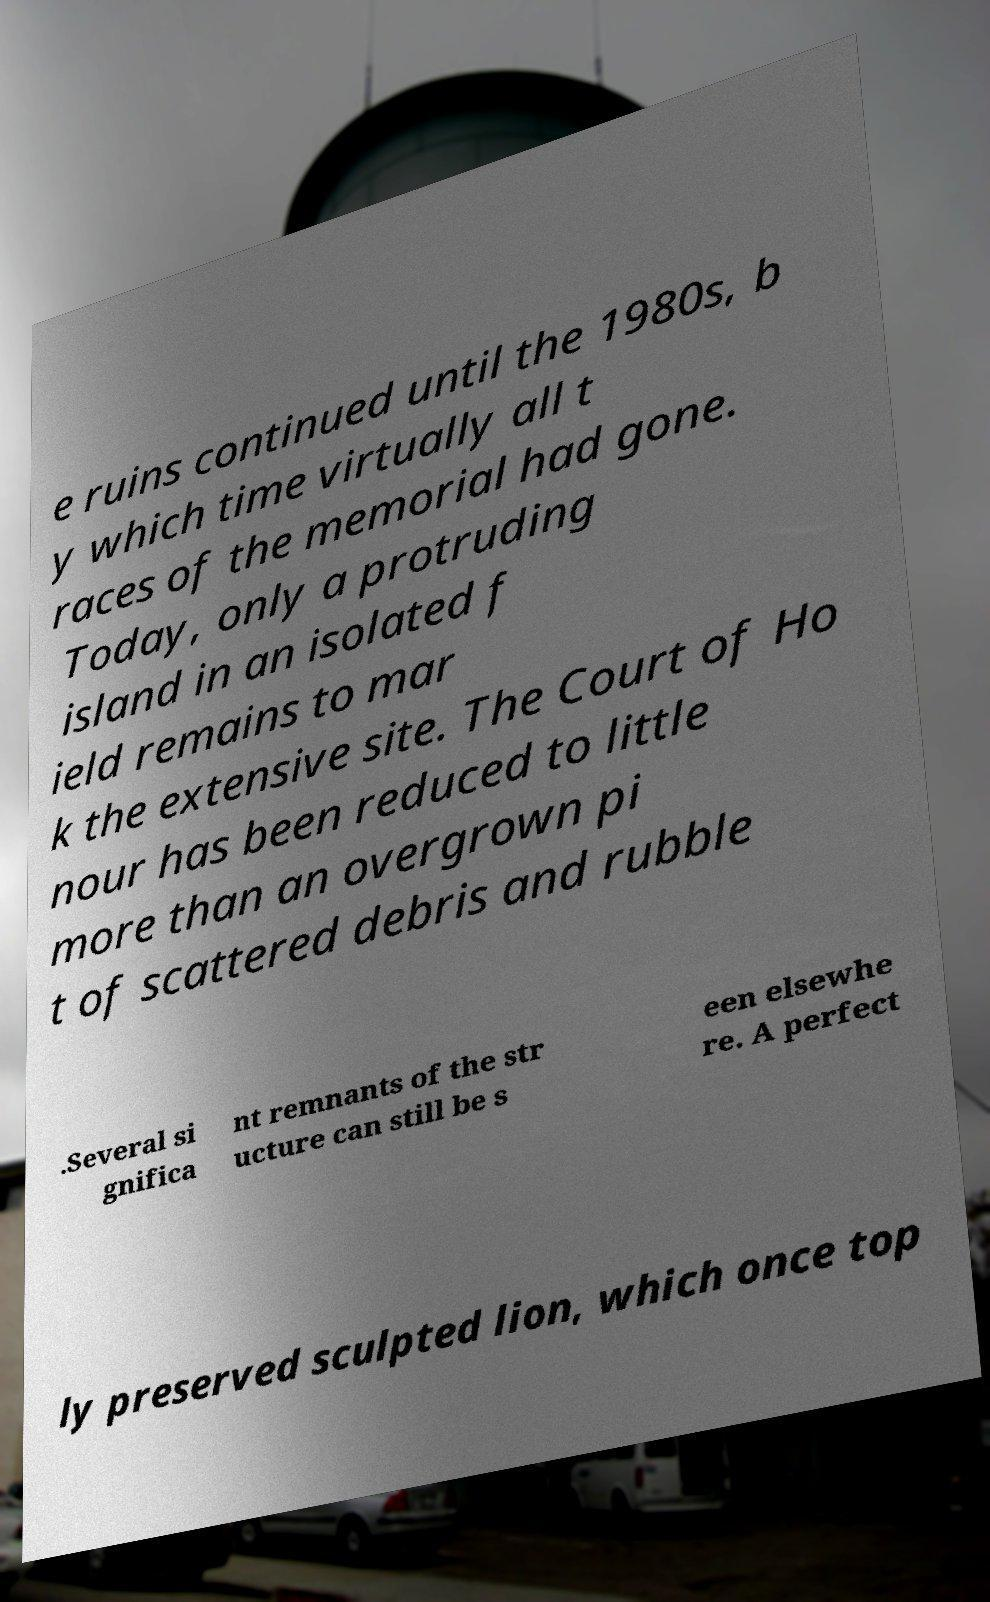Can you accurately transcribe the text from the provided image for me? e ruins continued until the 1980s, b y which time virtually all t races of the memorial had gone. Today, only a protruding island in an isolated f ield remains to mar k the extensive site. The Court of Ho nour has been reduced to little more than an overgrown pi t of scattered debris and rubble .Several si gnifica nt remnants of the str ucture can still be s een elsewhe re. A perfect ly preserved sculpted lion, which once top 